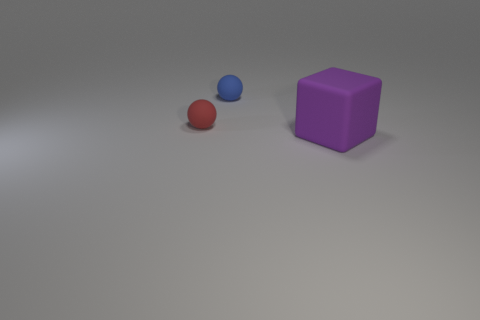Add 3 big matte blocks. How many objects exist? 6 Subtract 0 yellow blocks. How many objects are left? 3 Subtract all cubes. How many objects are left? 2 Subtract 1 spheres. How many spheres are left? 1 Subtract all green spheres. Subtract all brown blocks. How many spheres are left? 2 Subtract all big red balls. Subtract all tiny blue rubber balls. How many objects are left? 2 Add 2 small rubber spheres. How many small rubber spheres are left? 4 Add 2 small red objects. How many small red objects exist? 3 